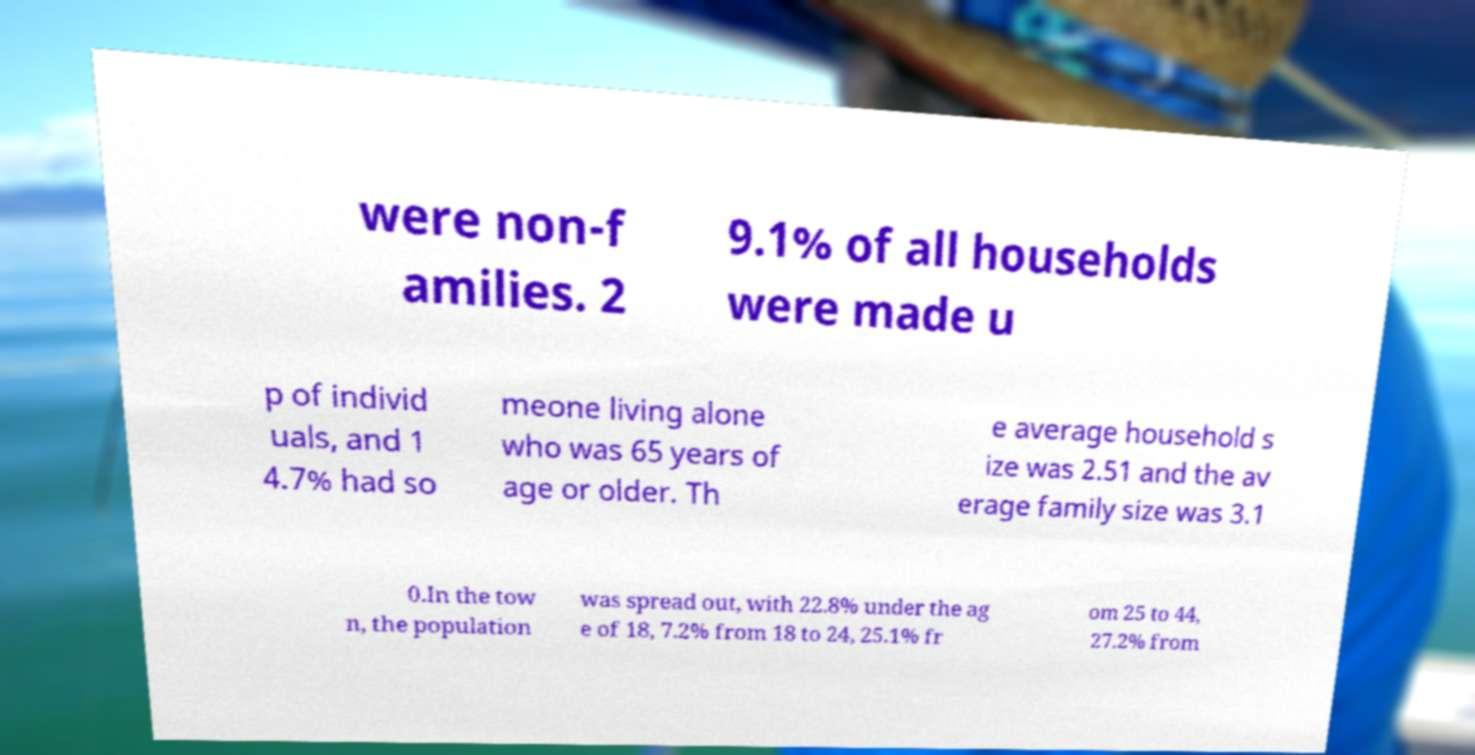What messages or text are displayed in this image? I need them in a readable, typed format. were non-f amilies. 2 9.1% of all households were made u p of individ uals, and 1 4.7% had so meone living alone who was 65 years of age or older. Th e average household s ize was 2.51 and the av erage family size was 3.1 0.In the tow n, the population was spread out, with 22.8% under the ag e of 18, 7.2% from 18 to 24, 25.1% fr om 25 to 44, 27.2% from 